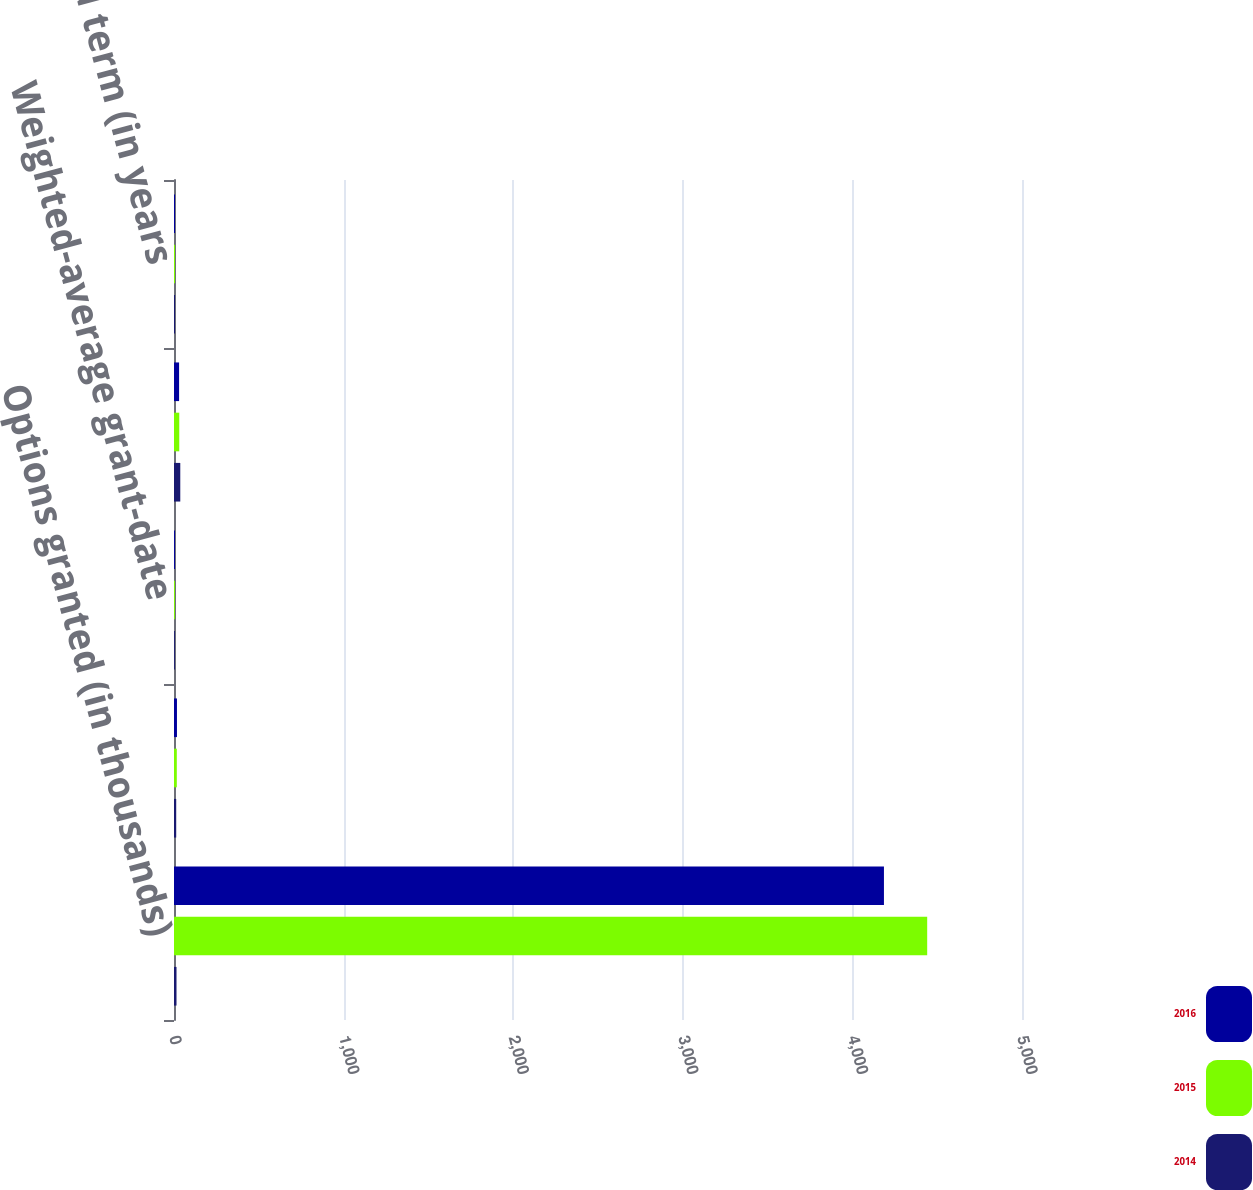Convert chart to OTSL. <chart><loc_0><loc_0><loc_500><loc_500><stacked_bar_chart><ecel><fcel>Options granted (in thousands)<fcel>Weighted-average exercise<fcel>Weighted-average grant-date<fcel>Expected volatility<fcel>Expected term (in years<nl><fcel>2016<fcel>4186<fcel>17.46<fcel>5.6<fcel>30<fcel>6<nl><fcel>2015<fcel>4441<fcel>16.49<fcel>5.54<fcel>31<fcel>6<nl><fcel>2014<fcel>14.755<fcel>13.02<fcel>5.07<fcel>37<fcel>6<nl></chart> 